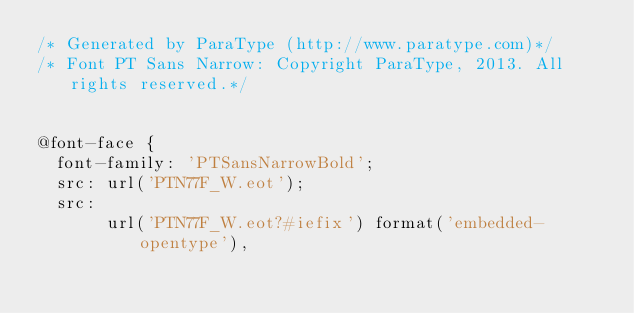Convert code to text. <code><loc_0><loc_0><loc_500><loc_500><_CSS_>/* Generated by ParaType (http://www.paratype.com)*/
/* Font PT Sans Narrow: Copyright ParaType, 2013. All rights reserved.*/


@font-face {
	font-family: 'PTSansNarrowBold';
	src: url('PTN77F_W.eot');
	src:
	     url('PTN77F_W.eot?#iefix') format('embedded-opentype'),</code> 